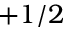<formula> <loc_0><loc_0><loc_500><loc_500>+ 1 / 2</formula> 